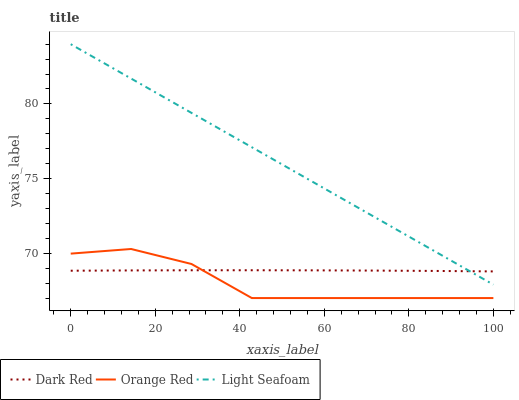Does Orange Red have the minimum area under the curve?
Answer yes or no. Yes. Does Light Seafoam have the maximum area under the curve?
Answer yes or no. Yes. Does Light Seafoam have the minimum area under the curve?
Answer yes or no. No. Does Orange Red have the maximum area under the curve?
Answer yes or no. No. Is Light Seafoam the smoothest?
Answer yes or no. Yes. Is Orange Red the roughest?
Answer yes or no. Yes. Is Orange Red the smoothest?
Answer yes or no. No. Is Light Seafoam the roughest?
Answer yes or no. No. Does Orange Red have the lowest value?
Answer yes or no. Yes. Does Light Seafoam have the lowest value?
Answer yes or no. No. Does Light Seafoam have the highest value?
Answer yes or no. Yes. Does Orange Red have the highest value?
Answer yes or no. No. Is Orange Red less than Light Seafoam?
Answer yes or no. Yes. Is Light Seafoam greater than Orange Red?
Answer yes or no. Yes. Does Dark Red intersect Light Seafoam?
Answer yes or no. Yes. Is Dark Red less than Light Seafoam?
Answer yes or no. No. Is Dark Red greater than Light Seafoam?
Answer yes or no. No. Does Orange Red intersect Light Seafoam?
Answer yes or no. No. 